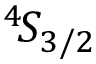Convert formula to latex. <formula><loc_0><loc_0><loc_500><loc_500>{ } ^ { 4 } \, S _ { 3 / 2 }</formula> 